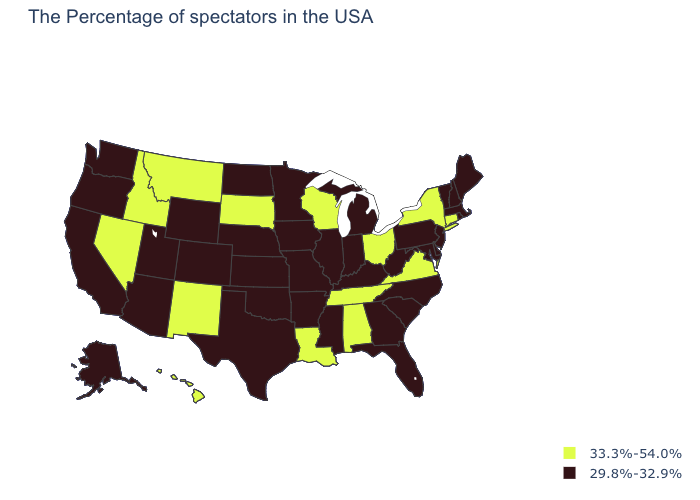Among the states that border New Hampshire , which have the lowest value?
Keep it brief. Maine, Massachusetts, Vermont. What is the value of Idaho?
Concise answer only. 33.3%-54.0%. Does the first symbol in the legend represent the smallest category?
Answer briefly. No. What is the value of Wyoming?
Give a very brief answer. 29.8%-32.9%. What is the value of Wisconsin?
Give a very brief answer. 33.3%-54.0%. Is the legend a continuous bar?
Write a very short answer. No. What is the highest value in the USA?
Be succinct. 33.3%-54.0%. What is the value of Alabama?
Write a very short answer. 33.3%-54.0%. Name the states that have a value in the range 33.3%-54.0%?
Quick response, please. Connecticut, New York, Virginia, Ohio, Alabama, Tennessee, Wisconsin, Louisiana, South Dakota, New Mexico, Montana, Idaho, Nevada, Hawaii. What is the lowest value in the Northeast?
Give a very brief answer. 29.8%-32.9%. Name the states that have a value in the range 33.3%-54.0%?
Give a very brief answer. Connecticut, New York, Virginia, Ohio, Alabama, Tennessee, Wisconsin, Louisiana, South Dakota, New Mexico, Montana, Idaho, Nevada, Hawaii. What is the value of Oregon?
Keep it brief. 29.8%-32.9%. Which states have the highest value in the USA?
Be succinct. Connecticut, New York, Virginia, Ohio, Alabama, Tennessee, Wisconsin, Louisiana, South Dakota, New Mexico, Montana, Idaho, Nevada, Hawaii. Does the first symbol in the legend represent the smallest category?
Be succinct. No. 